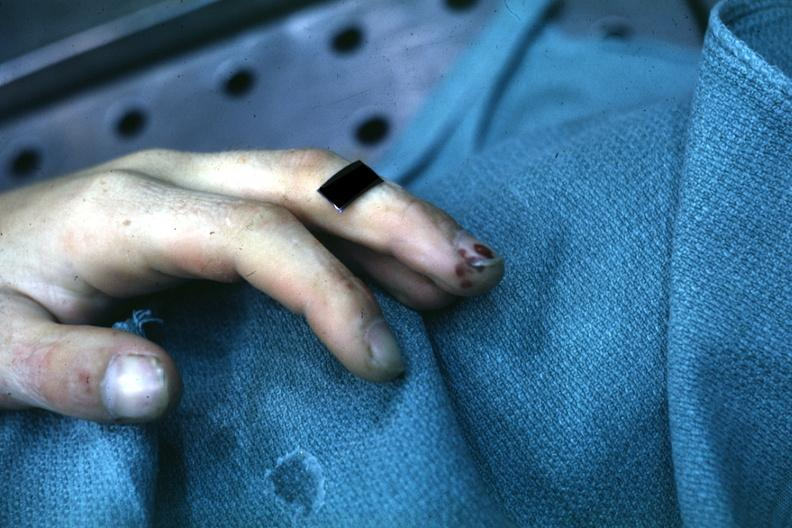what does this image show?
Answer the question using a single word or phrase. Lesions well shown on index finger staphylococcus 